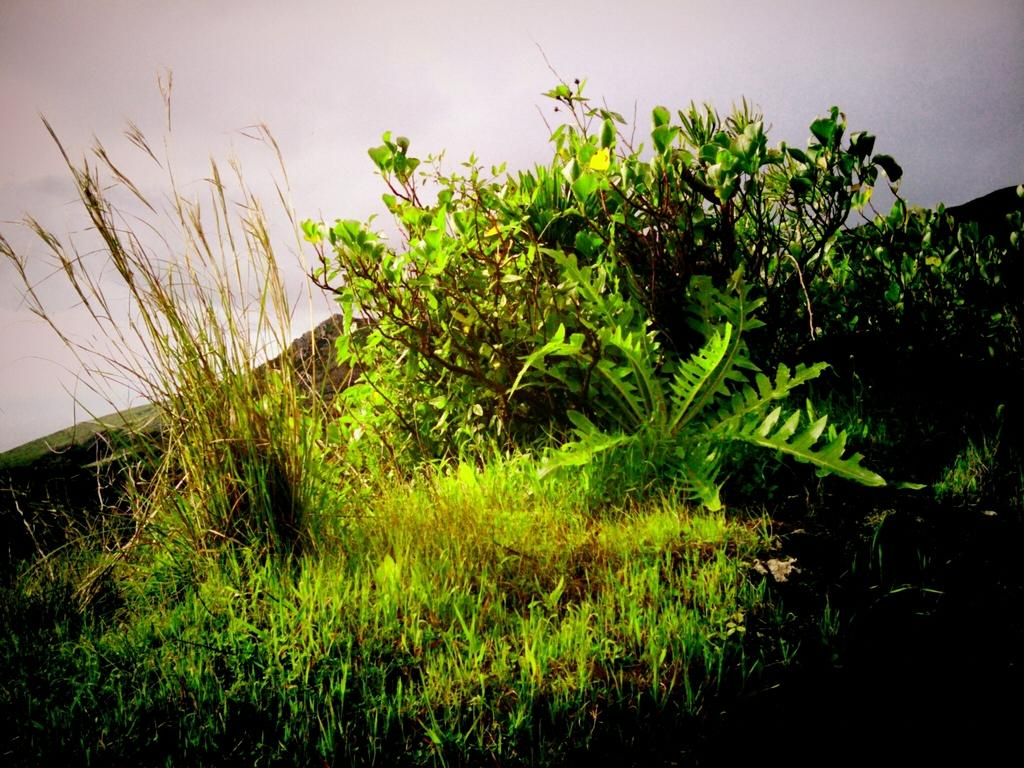What types of living organisms can be seen in the image? Plants and grass are visible in the image. What is the condition of the sky in the image? The sky is cloudy in the image. What time does the clock in the image show? There is no clock present in the image. What type of butter can be seen melting on the corn in the image? There is no butter or corn present in the image. 